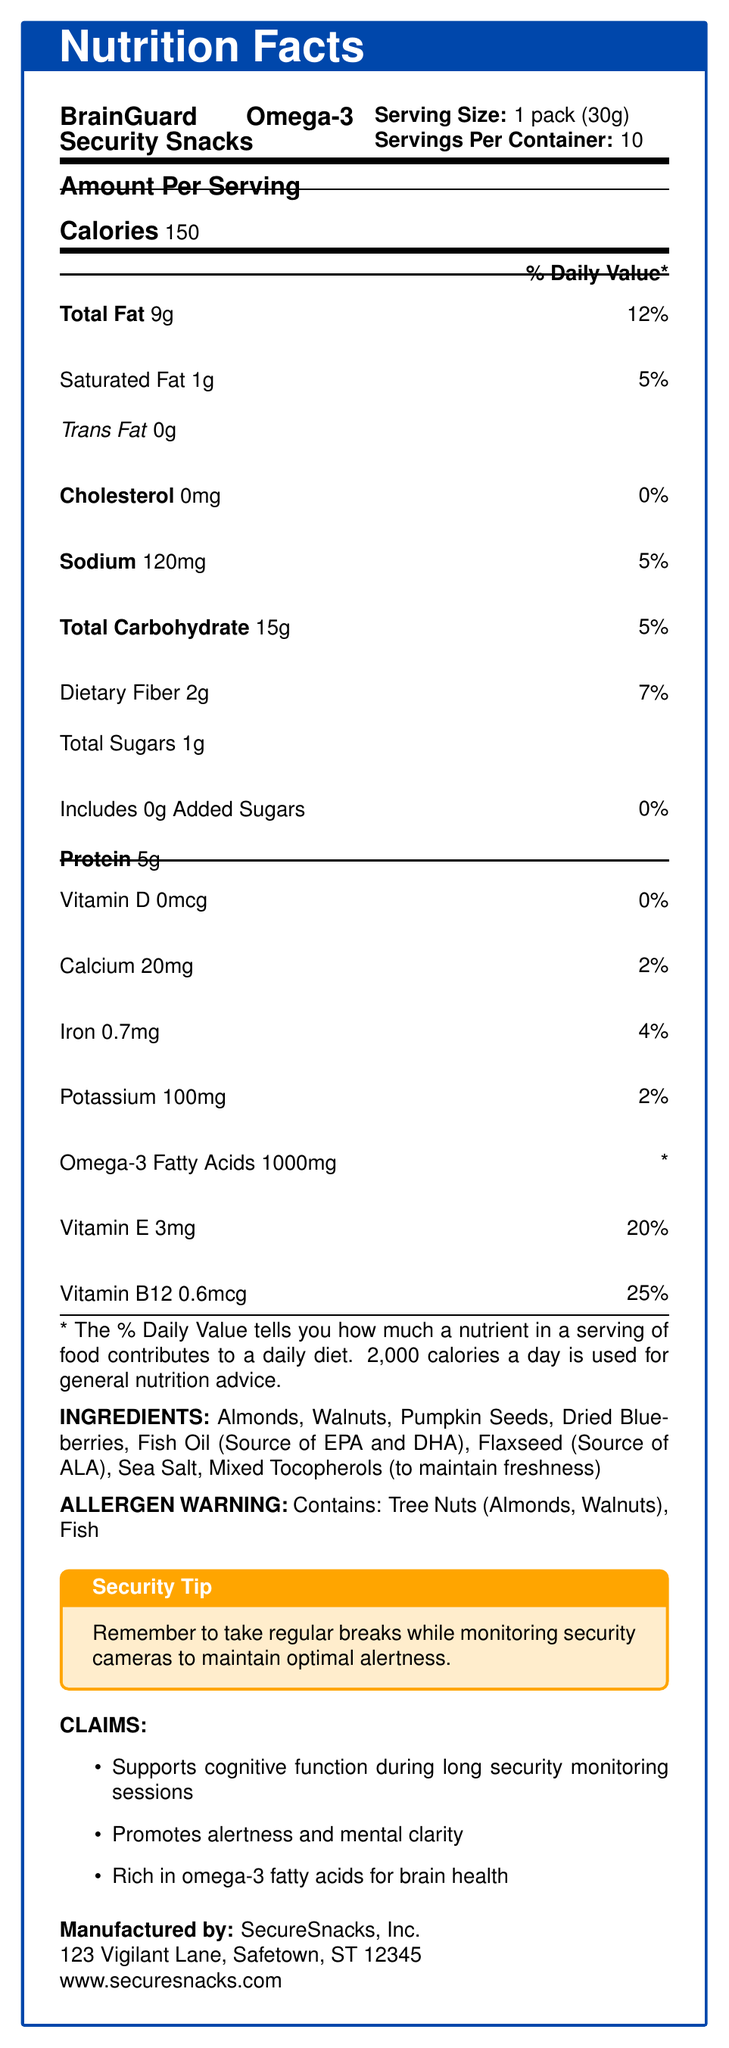what is the serving size of BrainGuard Omega-3 Security Snacks? The serving size is displayed in the top section of the Nutrition Facts label.
Answer: 1 pack (30g) how many calories are there per serving? The calories per serving are listed under the "Amount Per Serving" section.
Answer: 150 what is the percentage of daily value for total fat per serving? The percentage of daily value for total fat is listed beside the total fat amount in grams.
Answer: 12% how much omega-3 fatty acids are in one serving? The amount of omega-3 fatty acids per serving is shown under the nutritional information.
Answer: 1000mg does this product contain any added sugars? The document specifies that the product includes 0g of added sugars with a 0% daily value.
Answer: No which ingredient is a source of EPA and DHA? A. Flaxseed B. Fish Oil C. Almonds D. Walnuts The document lists "Fish Oil (Source of EPA and DHA)" under the ingredients section.
Answer: B how much vitamin E is included per serving? A. 2mg B. 3mg C. 4mg D. 5mg The amount of vitamin E per serving is listed as 3mg with a daily value of 20%.
Answer: B what is the percent daily value for vitamin B12 per serving? The percent daily value for vitamin B12 is displayed under the nutritional information for vitamins.
Answer: 25% does this product contain tree nuts? The allergen warning clearly states that the product contains tree nuts (Almonds, Walnuts).
Answer: Yes briefly summarize the main idea of the document. This summary captures the overall content of the document, including its nutritional aspects, intended benefits, and additional information like manufacturer details and a security tip.
Answer: The document provides the Nutrition Facts for BrainGuard Omega-3 Security Snacks, including the serving size, calories, amounts and percent daily values of various nutrients, ingredients, allergen warnings, claim statements, and a security tip. The product emphasizes cognitive support and alertness, essential for long security monitoring sessions. can I find out how long this product can stay fresh from the document? The document does not provide any information on the product’s shelf life or freshness duration.
Answer: Not enough information what is one of the recommended practices for maintaining optimal alertness while monitoring security cameras? The security tip at the bottom of the document advises taking regular breaks to maintain optimal alertness.
Answer: Take regular breaks 